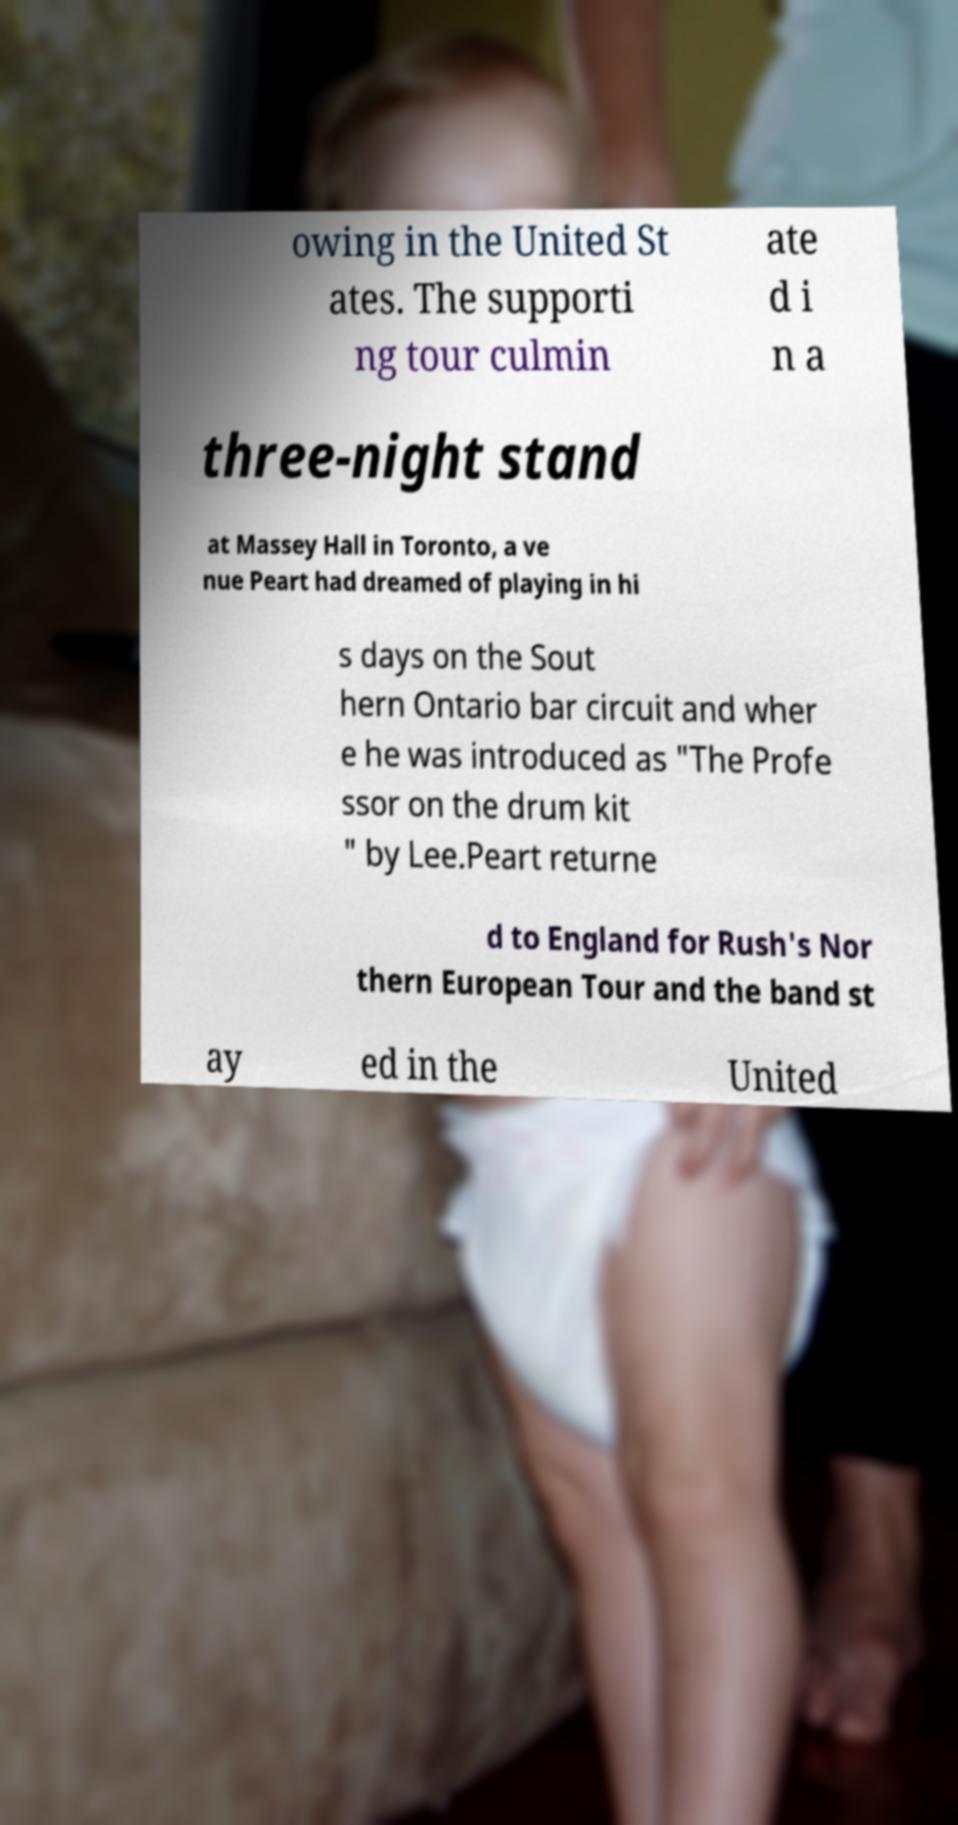Could you extract and type out the text from this image? owing in the United St ates. The supporti ng tour culmin ate d i n a three-night stand at Massey Hall in Toronto, a ve nue Peart had dreamed of playing in hi s days on the Sout hern Ontario bar circuit and wher e he was introduced as "The Profe ssor on the drum kit " by Lee.Peart returne d to England for Rush's Nor thern European Tour and the band st ay ed in the United 